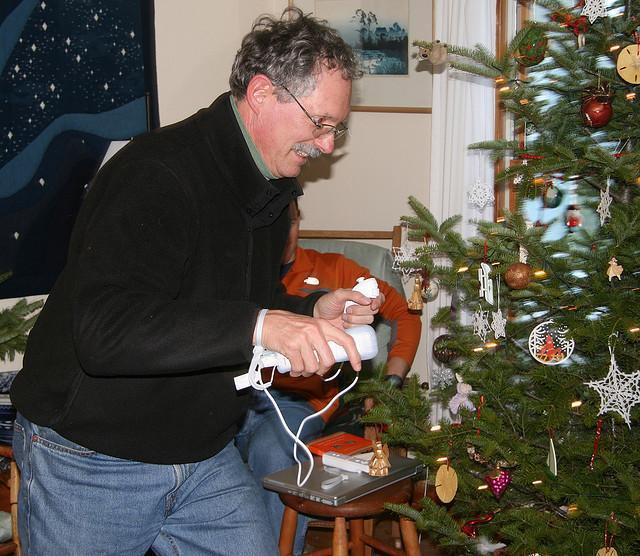What is the month depicted in the image?
From the following set of four choices, select the accurate answer to respond to the question.
Options: November, december, january, february. December. 